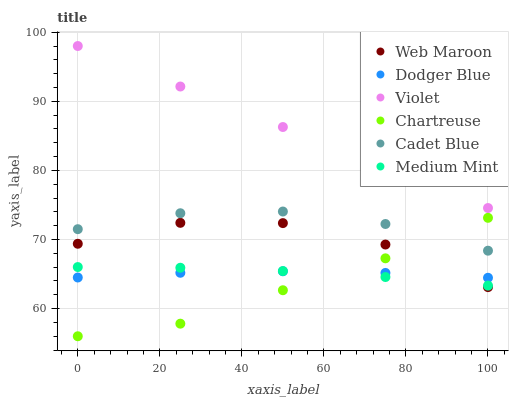Does Chartreuse have the minimum area under the curve?
Answer yes or no. Yes. Does Violet have the maximum area under the curve?
Answer yes or no. Yes. Does Cadet Blue have the minimum area under the curve?
Answer yes or no. No. Does Cadet Blue have the maximum area under the curve?
Answer yes or no. No. Is Violet the smoothest?
Answer yes or no. Yes. Is Web Maroon the roughest?
Answer yes or no. Yes. Is Cadet Blue the smoothest?
Answer yes or no. No. Is Cadet Blue the roughest?
Answer yes or no. No. Does Chartreuse have the lowest value?
Answer yes or no. Yes. Does Cadet Blue have the lowest value?
Answer yes or no. No. Does Violet have the highest value?
Answer yes or no. Yes. Does Cadet Blue have the highest value?
Answer yes or no. No. Is Dodger Blue less than Violet?
Answer yes or no. Yes. Is Violet greater than Chartreuse?
Answer yes or no. Yes. Does Dodger Blue intersect Chartreuse?
Answer yes or no. Yes. Is Dodger Blue less than Chartreuse?
Answer yes or no. No. Is Dodger Blue greater than Chartreuse?
Answer yes or no. No. Does Dodger Blue intersect Violet?
Answer yes or no. No. 